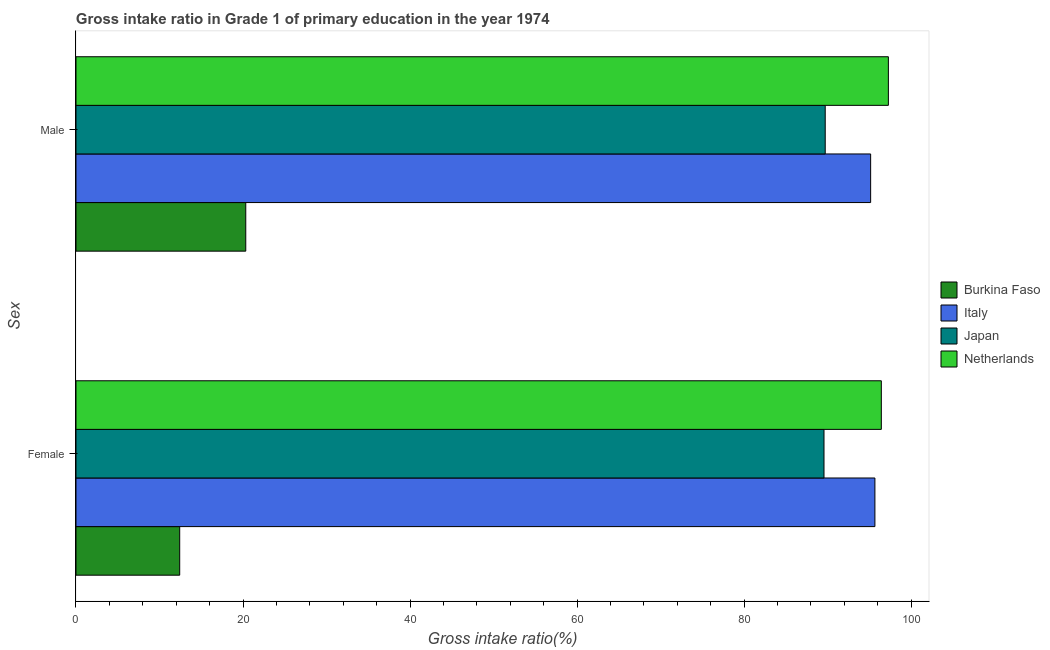How many different coloured bars are there?
Keep it short and to the point. 4. How many groups of bars are there?
Offer a terse response. 2. Are the number of bars on each tick of the Y-axis equal?
Keep it short and to the point. Yes. How many bars are there on the 1st tick from the bottom?
Keep it short and to the point. 4. What is the gross intake ratio(male) in Japan?
Offer a very short reply. 89.71. Across all countries, what is the maximum gross intake ratio(male)?
Provide a short and direct response. 97.27. Across all countries, what is the minimum gross intake ratio(male)?
Your answer should be very brief. 20.33. In which country was the gross intake ratio(male) minimum?
Keep it short and to the point. Burkina Faso. What is the total gross intake ratio(female) in the graph?
Give a very brief answer. 294.07. What is the difference between the gross intake ratio(male) in Italy and that in Japan?
Offer a very short reply. 5.44. What is the difference between the gross intake ratio(male) in Netherlands and the gross intake ratio(female) in Japan?
Give a very brief answer. 7.71. What is the average gross intake ratio(male) per country?
Your answer should be very brief. 75.61. What is the difference between the gross intake ratio(male) and gross intake ratio(female) in Japan?
Offer a very short reply. 0.15. In how many countries, is the gross intake ratio(female) greater than 60 %?
Provide a short and direct response. 3. What is the ratio of the gross intake ratio(female) in Italy to that in Burkina Faso?
Your response must be concise. 7.7. What does the 4th bar from the top in Female represents?
Keep it short and to the point. Burkina Faso. What does the 2nd bar from the bottom in Male represents?
Provide a succinct answer. Italy. How many bars are there?
Your answer should be compact. 8. Are all the bars in the graph horizontal?
Provide a succinct answer. Yes. What is the difference between two consecutive major ticks on the X-axis?
Give a very brief answer. 20. Are the values on the major ticks of X-axis written in scientific E-notation?
Your response must be concise. No. Does the graph contain any zero values?
Make the answer very short. No. Where does the legend appear in the graph?
Your answer should be compact. Center right. How many legend labels are there?
Offer a terse response. 4. What is the title of the graph?
Give a very brief answer. Gross intake ratio in Grade 1 of primary education in the year 1974. What is the label or title of the X-axis?
Provide a succinct answer. Gross intake ratio(%). What is the label or title of the Y-axis?
Provide a short and direct response. Sex. What is the Gross intake ratio(%) of Burkina Faso in Female?
Offer a terse response. 12.42. What is the Gross intake ratio(%) in Italy in Female?
Keep it short and to the point. 95.66. What is the Gross intake ratio(%) of Japan in Female?
Keep it short and to the point. 89.56. What is the Gross intake ratio(%) in Netherlands in Female?
Your answer should be compact. 96.43. What is the Gross intake ratio(%) of Burkina Faso in Male?
Provide a short and direct response. 20.33. What is the Gross intake ratio(%) of Italy in Male?
Your answer should be compact. 95.15. What is the Gross intake ratio(%) in Japan in Male?
Your response must be concise. 89.71. What is the Gross intake ratio(%) in Netherlands in Male?
Give a very brief answer. 97.27. Across all Sex, what is the maximum Gross intake ratio(%) in Burkina Faso?
Offer a terse response. 20.33. Across all Sex, what is the maximum Gross intake ratio(%) of Italy?
Your answer should be very brief. 95.66. Across all Sex, what is the maximum Gross intake ratio(%) of Japan?
Offer a very short reply. 89.71. Across all Sex, what is the maximum Gross intake ratio(%) in Netherlands?
Offer a terse response. 97.27. Across all Sex, what is the minimum Gross intake ratio(%) in Burkina Faso?
Make the answer very short. 12.42. Across all Sex, what is the minimum Gross intake ratio(%) of Italy?
Provide a short and direct response. 95.15. Across all Sex, what is the minimum Gross intake ratio(%) of Japan?
Offer a terse response. 89.56. Across all Sex, what is the minimum Gross intake ratio(%) in Netherlands?
Provide a succinct answer. 96.43. What is the total Gross intake ratio(%) in Burkina Faso in the graph?
Give a very brief answer. 32.75. What is the total Gross intake ratio(%) in Italy in the graph?
Give a very brief answer. 190.81. What is the total Gross intake ratio(%) in Japan in the graph?
Offer a very short reply. 179.27. What is the total Gross intake ratio(%) in Netherlands in the graph?
Make the answer very short. 193.7. What is the difference between the Gross intake ratio(%) in Burkina Faso in Female and that in Male?
Your answer should be very brief. -7.91. What is the difference between the Gross intake ratio(%) of Italy in Female and that in Male?
Your response must be concise. 0.51. What is the difference between the Gross intake ratio(%) of Japan in Female and that in Male?
Ensure brevity in your answer.  -0.15. What is the difference between the Gross intake ratio(%) of Netherlands in Female and that in Male?
Your answer should be compact. -0.84. What is the difference between the Gross intake ratio(%) of Burkina Faso in Female and the Gross intake ratio(%) of Italy in Male?
Give a very brief answer. -82.73. What is the difference between the Gross intake ratio(%) of Burkina Faso in Female and the Gross intake ratio(%) of Japan in Male?
Offer a very short reply. -77.29. What is the difference between the Gross intake ratio(%) in Burkina Faso in Female and the Gross intake ratio(%) in Netherlands in Male?
Your answer should be very brief. -84.85. What is the difference between the Gross intake ratio(%) of Italy in Female and the Gross intake ratio(%) of Japan in Male?
Keep it short and to the point. 5.95. What is the difference between the Gross intake ratio(%) of Italy in Female and the Gross intake ratio(%) of Netherlands in Male?
Offer a terse response. -1.61. What is the difference between the Gross intake ratio(%) of Japan in Female and the Gross intake ratio(%) of Netherlands in Male?
Your response must be concise. -7.71. What is the average Gross intake ratio(%) of Burkina Faso per Sex?
Ensure brevity in your answer.  16.37. What is the average Gross intake ratio(%) of Italy per Sex?
Keep it short and to the point. 95.4. What is the average Gross intake ratio(%) of Japan per Sex?
Offer a very short reply. 89.64. What is the average Gross intake ratio(%) of Netherlands per Sex?
Your answer should be very brief. 96.85. What is the difference between the Gross intake ratio(%) in Burkina Faso and Gross intake ratio(%) in Italy in Female?
Your answer should be compact. -83.24. What is the difference between the Gross intake ratio(%) of Burkina Faso and Gross intake ratio(%) of Japan in Female?
Provide a succinct answer. -77.14. What is the difference between the Gross intake ratio(%) in Burkina Faso and Gross intake ratio(%) in Netherlands in Female?
Your answer should be very brief. -84.01. What is the difference between the Gross intake ratio(%) of Italy and Gross intake ratio(%) of Japan in Female?
Provide a short and direct response. 6.1. What is the difference between the Gross intake ratio(%) in Italy and Gross intake ratio(%) in Netherlands in Female?
Provide a succinct answer. -0.77. What is the difference between the Gross intake ratio(%) of Japan and Gross intake ratio(%) of Netherlands in Female?
Your answer should be very brief. -6.87. What is the difference between the Gross intake ratio(%) of Burkina Faso and Gross intake ratio(%) of Italy in Male?
Give a very brief answer. -74.82. What is the difference between the Gross intake ratio(%) in Burkina Faso and Gross intake ratio(%) in Japan in Male?
Your answer should be very brief. -69.38. What is the difference between the Gross intake ratio(%) in Burkina Faso and Gross intake ratio(%) in Netherlands in Male?
Your answer should be very brief. -76.94. What is the difference between the Gross intake ratio(%) in Italy and Gross intake ratio(%) in Japan in Male?
Offer a very short reply. 5.44. What is the difference between the Gross intake ratio(%) in Italy and Gross intake ratio(%) in Netherlands in Male?
Provide a succinct answer. -2.12. What is the difference between the Gross intake ratio(%) in Japan and Gross intake ratio(%) in Netherlands in Male?
Provide a succinct answer. -7.56. What is the ratio of the Gross intake ratio(%) in Burkina Faso in Female to that in Male?
Provide a short and direct response. 0.61. What is the ratio of the Gross intake ratio(%) in Italy in Female to that in Male?
Provide a short and direct response. 1.01. What is the ratio of the Gross intake ratio(%) of Netherlands in Female to that in Male?
Provide a short and direct response. 0.99. What is the difference between the highest and the second highest Gross intake ratio(%) of Burkina Faso?
Make the answer very short. 7.91. What is the difference between the highest and the second highest Gross intake ratio(%) in Italy?
Provide a succinct answer. 0.51. What is the difference between the highest and the second highest Gross intake ratio(%) of Japan?
Make the answer very short. 0.15. What is the difference between the highest and the second highest Gross intake ratio(%) of Netherlands?
Offer a very short reply. 0.84. What is the difference between the highest and the lowest Gross intake ratio(%) of Burkina Faso?
Provide a short and direct response. 7.91. What is the difference between the highest and the lowest Gross intake ratio(%) in Italy?
Keep it short and to the point. 0.51. What is the difference between the highest and the lowest Gross intake ratio(%) of Japan?
Offer a terse response. 0.15. What is the difference between the highest and the lowest Gross intake ratio(%) of Netherlands?
Provide a short and direct response. 0.84. 